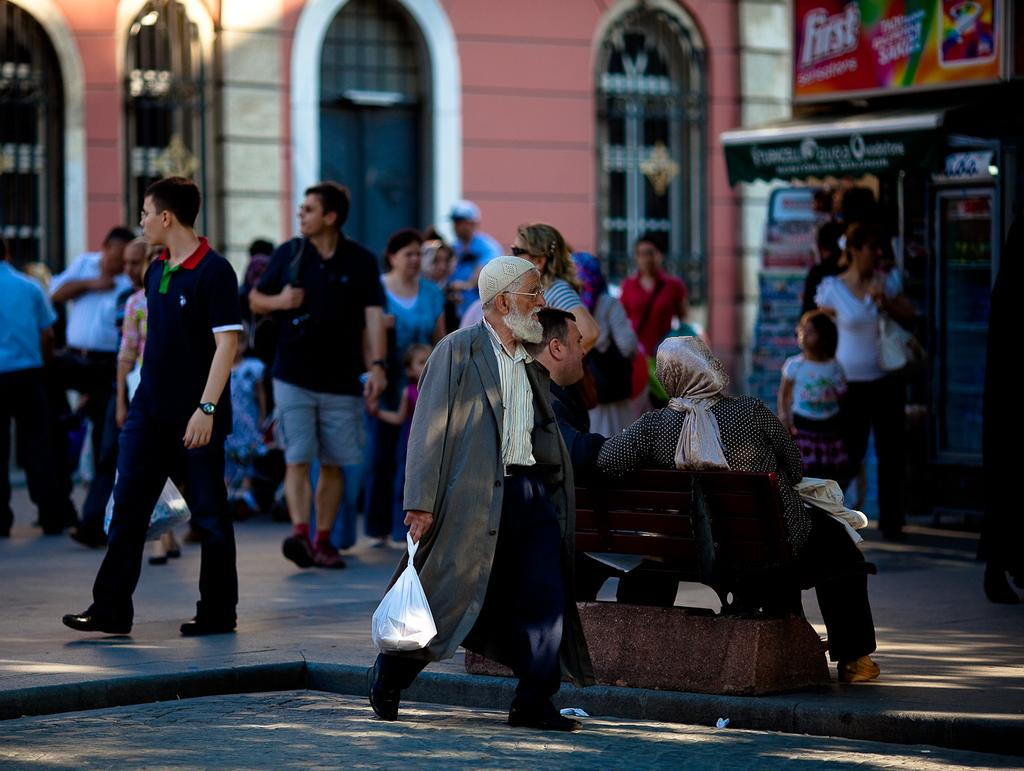What is happening on the road in the image? There are people on the road in the image. Can you describe the seating arrangement of the people in the image? Two people are sitting on a bench in the image. How many buildings can be seen in the image? There are two buildings in the image. What is attached to one of the buildings? There is a board attached to one of the buildings in the image. What type of produce is being transported by the rail in the image? There is no rail or produce present in the image. Is there any steam coming from the buildings in the image? There is no steam visible in the image. 